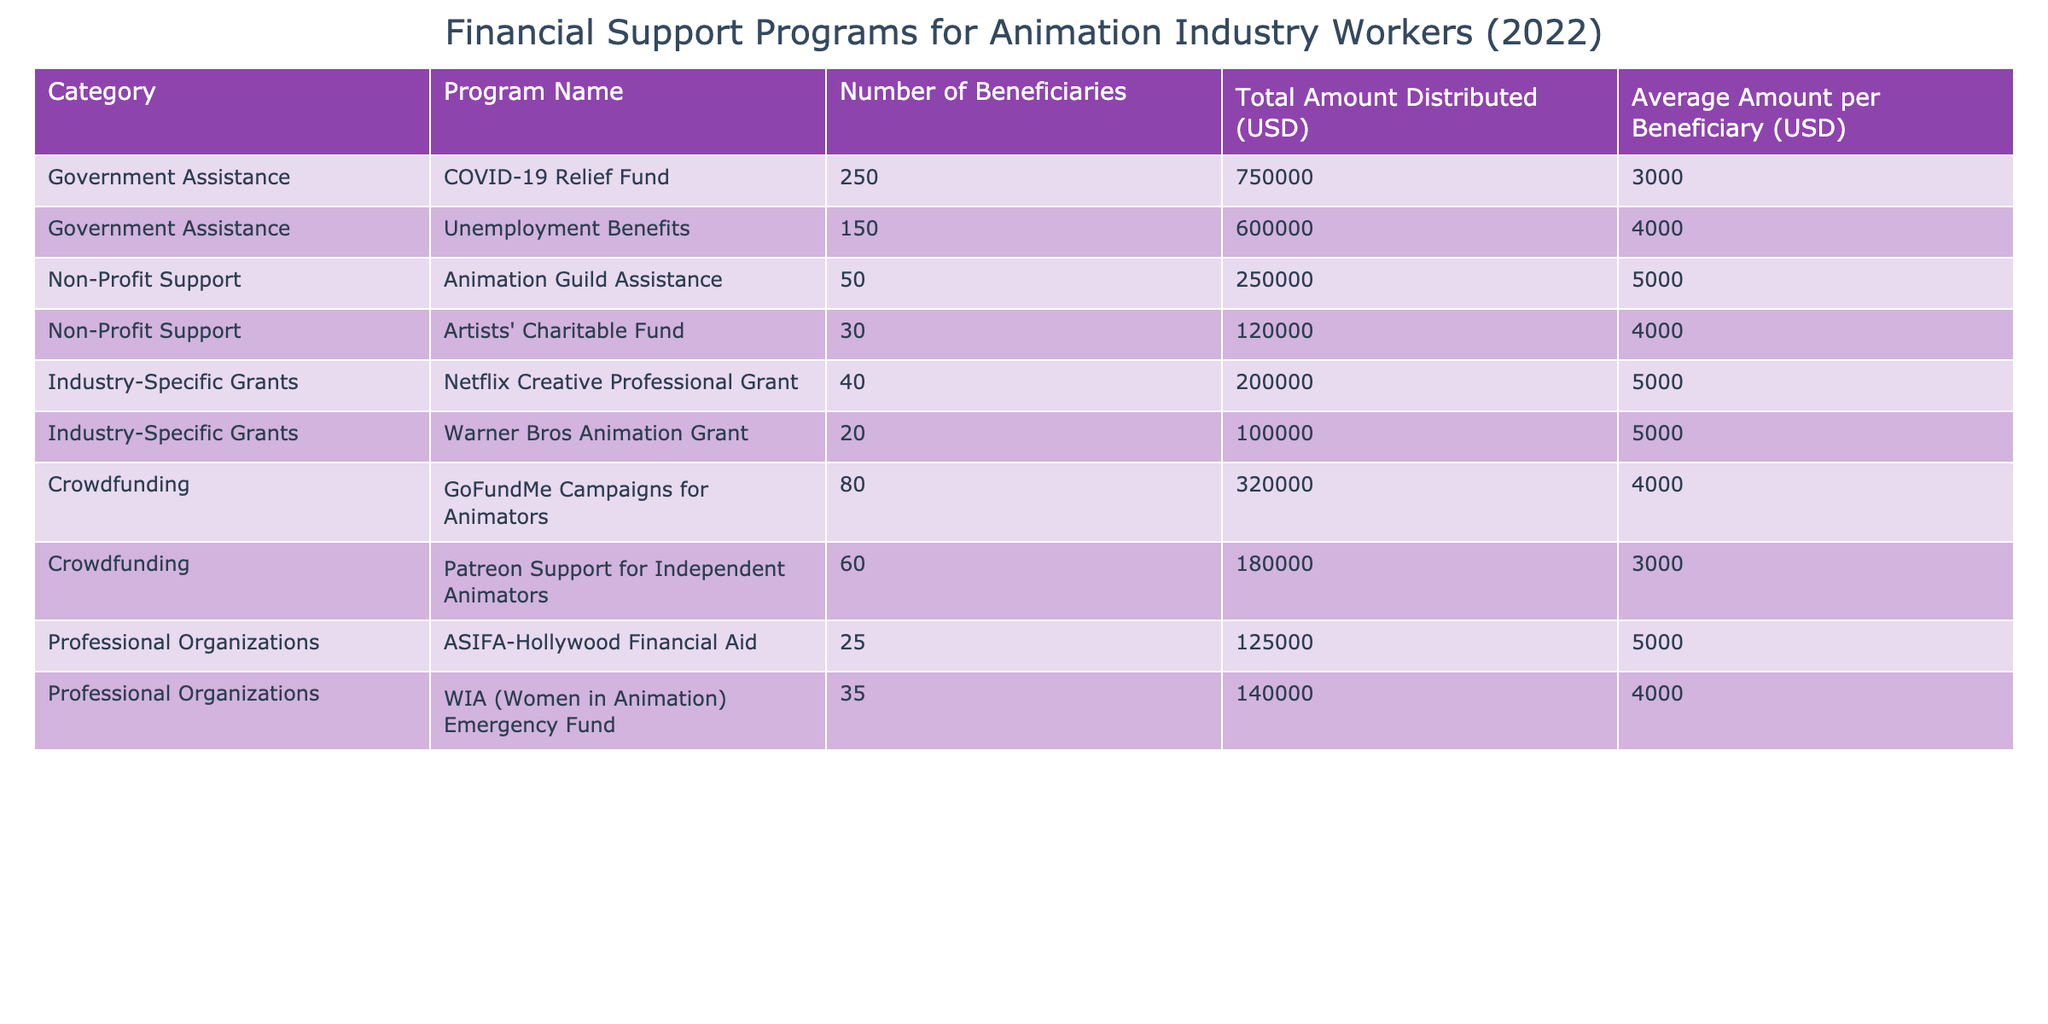What is the total amount distributed for the COVID-19 Relief Fund? The table lists the total amount distributed for the COVID-19 Relief Fund as USD 750,000.
Answer: 750,000 How many beneficiaries received support from the Animation Guild Assistance program? According to the table, 50 beneficiaries received support from the Animation Guild Assistance program.
Answer: 50 Which program had the highest average amount per beneficiary? The average amount per beneficiary for the Animation Guild Assistance program is USD 5,000, which is higher than any other program listed in the table.
Answer: Animation Guild Assistance What is the total number of beneficiaries across all Government Assistance programs? The COVID-19 Relief Fund had 250 beneficiaries and the Unemployment Benefits had 150 beneficiaries. The total is 250 + 150 = 400 beneficiaries.
Answer: 400 Did more people benefit from Unemployment Benefits than from the Warner Bros Animation Grant? The table shows that 150 beneficiaries received Unemployment Benefits, while only 20 benefited from the Warner Bros Animation Grant, confirming that more people did benefit from Unemployment Benefits.
Answer: Yes What is the average amount distributed per beneficiary for Industry-Specific Grants combined? There are 2 Industry-Specific Grants: the Netflix Creative Professional Grant with 40 beneficiaries receiving USD 200,000 (USD 5,000 each) and the Warner Bros Animation Grant with 20 beneficiaries receiving USD 100,000 (USD 5,000 each). Overall, 40 + 20 = 60 beneficiaries and USD 200,000 + USD 100,000 = USD 300,000 distributed. The average amount is USD 300,000 / 60 = USD 5,000.
Answer: 5,000 How much total funding was received by Crowdfunding programs? The GoFundMe Campaigns for Animators received USD 320,000 while the Patreon Support for Independent Animators received USD 180,000. Adding these amounts gives USD 320,000 + USD 180,000 = USD 500,000 total funding for Crowdfunding programs.
Answer: 500,000 Is it true that the Artists' Charitable Fund provided support to fewer beneficiaries than the WIA Emergency Fund? The table shows that the Artists' Charitable Fund supported 30 beneficiaries, while the WIA Emergency Fund supported 35 beneficiaries, making the statement true as 30 is fewer than 35.
Answer: Yes What percentage of total funding distributed came from Government Assistance programs? The total amount distributed from Government Assistance programs is USD 750,000 (COVID-19 Relief Fund) + USD 600,000 (Unemployment Benefits) = USD 1,350,000. The total amount distributed across all programs is USD 750,000 + USD 600,000 + USD 250,000 + USD 120,000 + USD 200,000 + USD 100,000 + USD 320,000 + USD 180,000 + USD 125,000 + USD 140,000 = USD 2,815,000. The percentage is (1,350,000 / 2,815,000) * 100 ≈ 47.87%.
Answer: Approximately 47.87% 